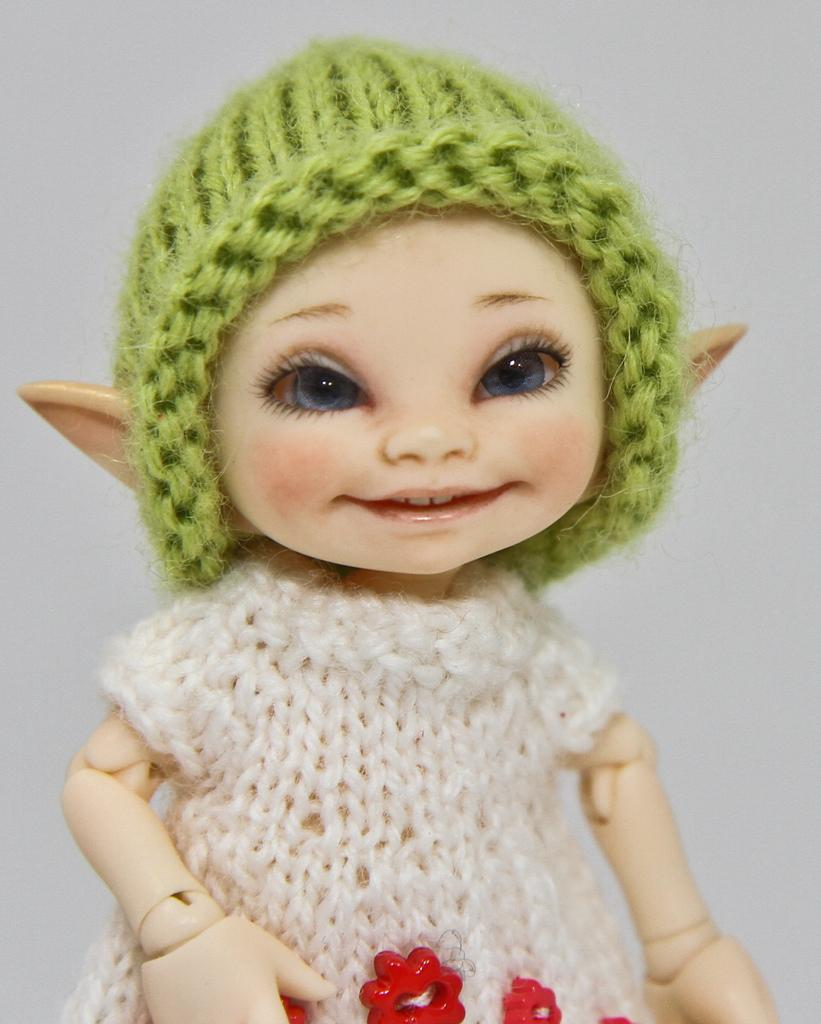What is the main subject of the image? There is a doll in the image. How is the doll dressed in the image? The doll is wrapped in crochet clothes. What colors are the crochet clothes? The crochet clothes are of white and green color. What type of apple is being polished in the image? There is no apple or polishing activity present in the image; it features a doll wrapped in crochet clothes. What religious symbol can be seen in the image? There is no religious symbol present in the image; it features a doll wrapped in crochet clothes. 